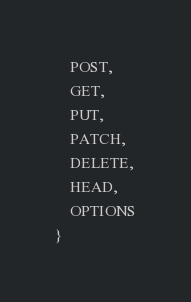<code> <loc_0><loc_0><loc_500><loc_500><_Java_>    POST,
    GET,
    PUT,
    PATCH,
    DELETE,
    HEAD,
    OPTIONS
}
</code> 